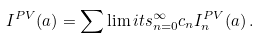<formula> <loc_0><loc_0><loc_500><loc_500>I ^ { P V } ( a ) = \sum \lim i t s _ { n = 0 } ^ { \infty } c _ { n } I ^ { P V } _ { n } ( a ) \, .</formula> 